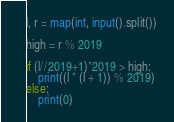<code> <loc_0><loc_0><loc_500><loc_500><_Python_>l, r = map(int, input().split())

high = r % 2019

if (l//2019+1)*2019 > high:
    print((l * (l + 1)) % 2019)
else:
    print(0)</code> 